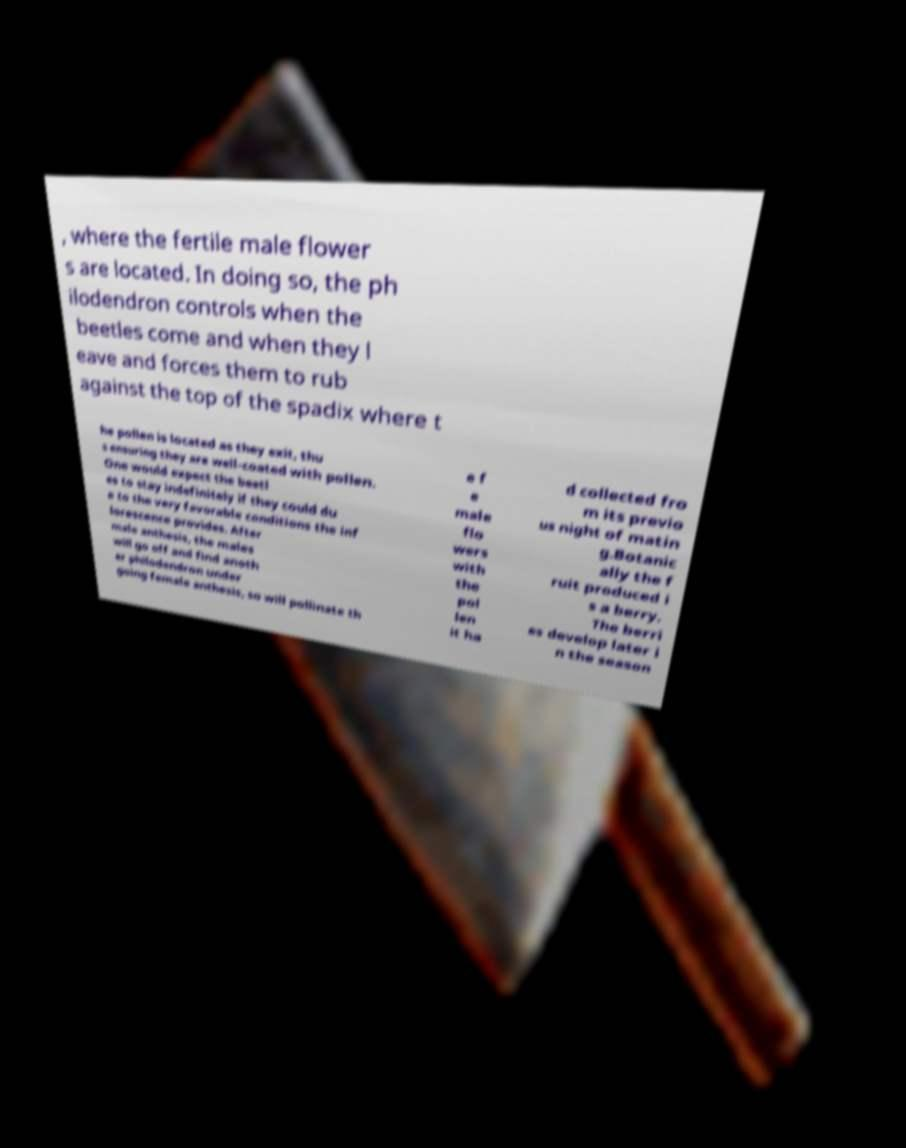Please read and relay the text visible in this image. What does it say? , where the fertile male flower s are located. In doing so, the ph ilodendron controls when the beetles come and when they l eave and forces them to rub against the top of the spadix where t he pollen is located as they exit, thu s ensuring they are well-coated with pollen. One would expect the beetl es to stay indefinitely if they could du e to the very favorable conditions the inf lorescence provides. After male anthesis, the males will go off and find anoth er philodendron under going female anthesis, so will pollinate th e f e male flo wers with the pol len it ha d collected fro m its previo us night of matin g.Botanic ally the f ruit produced i s a berry. The berri es develop later i n the season 